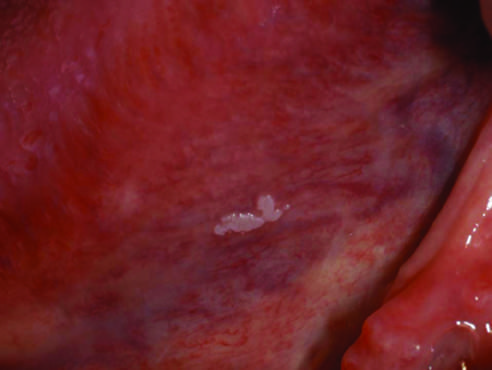what is highly variable?
Answer the question using a single word or phrase. Gross appearance of leukoplakia 